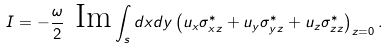Convert formula to latex. <formula><loc_0><loc_0><loc_500><loc_500>I = - \frac { \omega } { 2 } \text { Im} \int _ { s } d x d y \left ( u _ { x } \sigma _ { x z } ^ { \ast } + u _ { y } \sigma _ { y z } ^ { \ast } + u _ { z } \sigma _ { z z } ^ { \ast } \right ) _ { z = 0 } .</formula> 